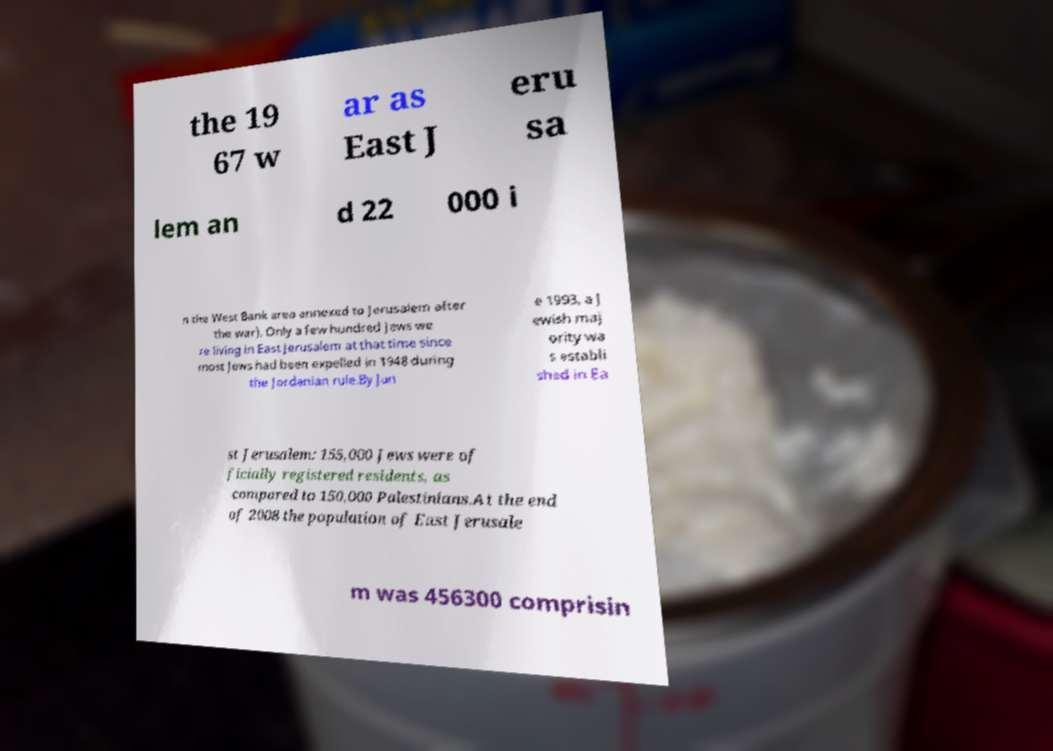Can you read and provide the text displayed in the image?This photo seems to have some interesting text. Can you extract and type it out for me? the 19 67 w ar as East J eru sa lem an d 22 000 i n the West Bank area annexed to Jerusalem after the war). Only a few hundred Jews we re living in East Jerusalem at that time since most Jews had been expelled in 1948 during the Jordanian rule.By Jun e 1993, a J ewish maj ority wa s establi shed in Ea st Jerusalem: 155,000 Jews were of ficially registered residents, as compared to 150,000 Palestinians.At the end of 2008 the population of East Jerusale m was 456300 comprisin 